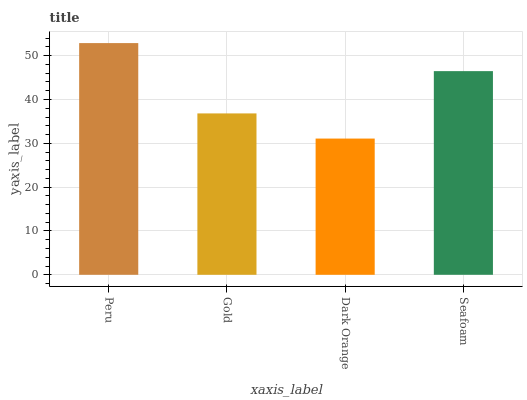Is Dark Orange the minimum?
Answer yes or no. Yes. Is Peru the maximum?
Answer yes or no. Yes. Is Gold the minimum?
Answer yes or no. No. Is Gold the maximum?
Answer yes or no. No. Is Peru greater than Gold?
Answer yes or no. Yes. Is Gold less than Peru?
Answer yes or no. Yes. Is Gold greater than Peru?
Answer yes or no. No. Is Peru less than Gold?
Answer yes or no. No. Is Seafoam the high median?
Answer yes or no. Yes. Is Gold the low median?
Answer yes or no. Yes. Is Dark Orange the high median?
Answer yes or no. No. Is Peru the low median?
Answer yes or no. No. 